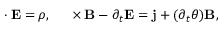<formula> <loc_0><loc_0><loc_500><loc_500>\nabla \cdot E = \rho , \quad \nabla \times B - \partial _ { t } E = j + ( \partial _ { t } \theta ) B ,</formula> 